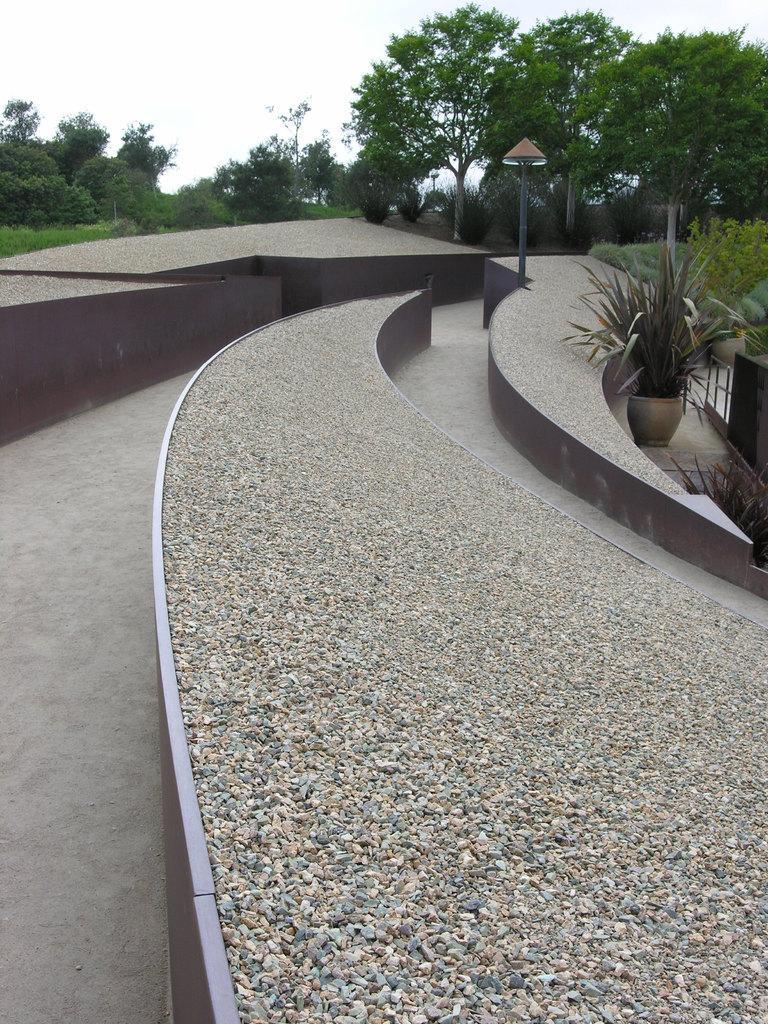Can you describe this image briefly? In this image I can see few plants and trees in green color and I can also see the board attached to the pole. Background the sky is in white color 